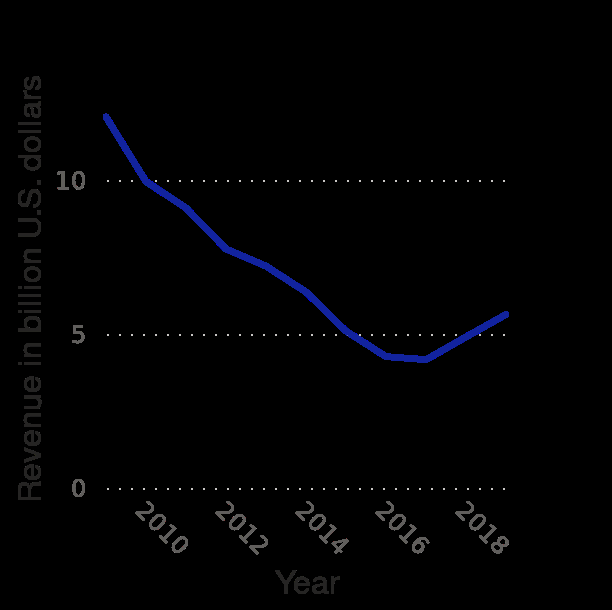<image>
Has the company's global revenue been stable before 2015? No, the company's global revenue has been decreasing before 2015. 